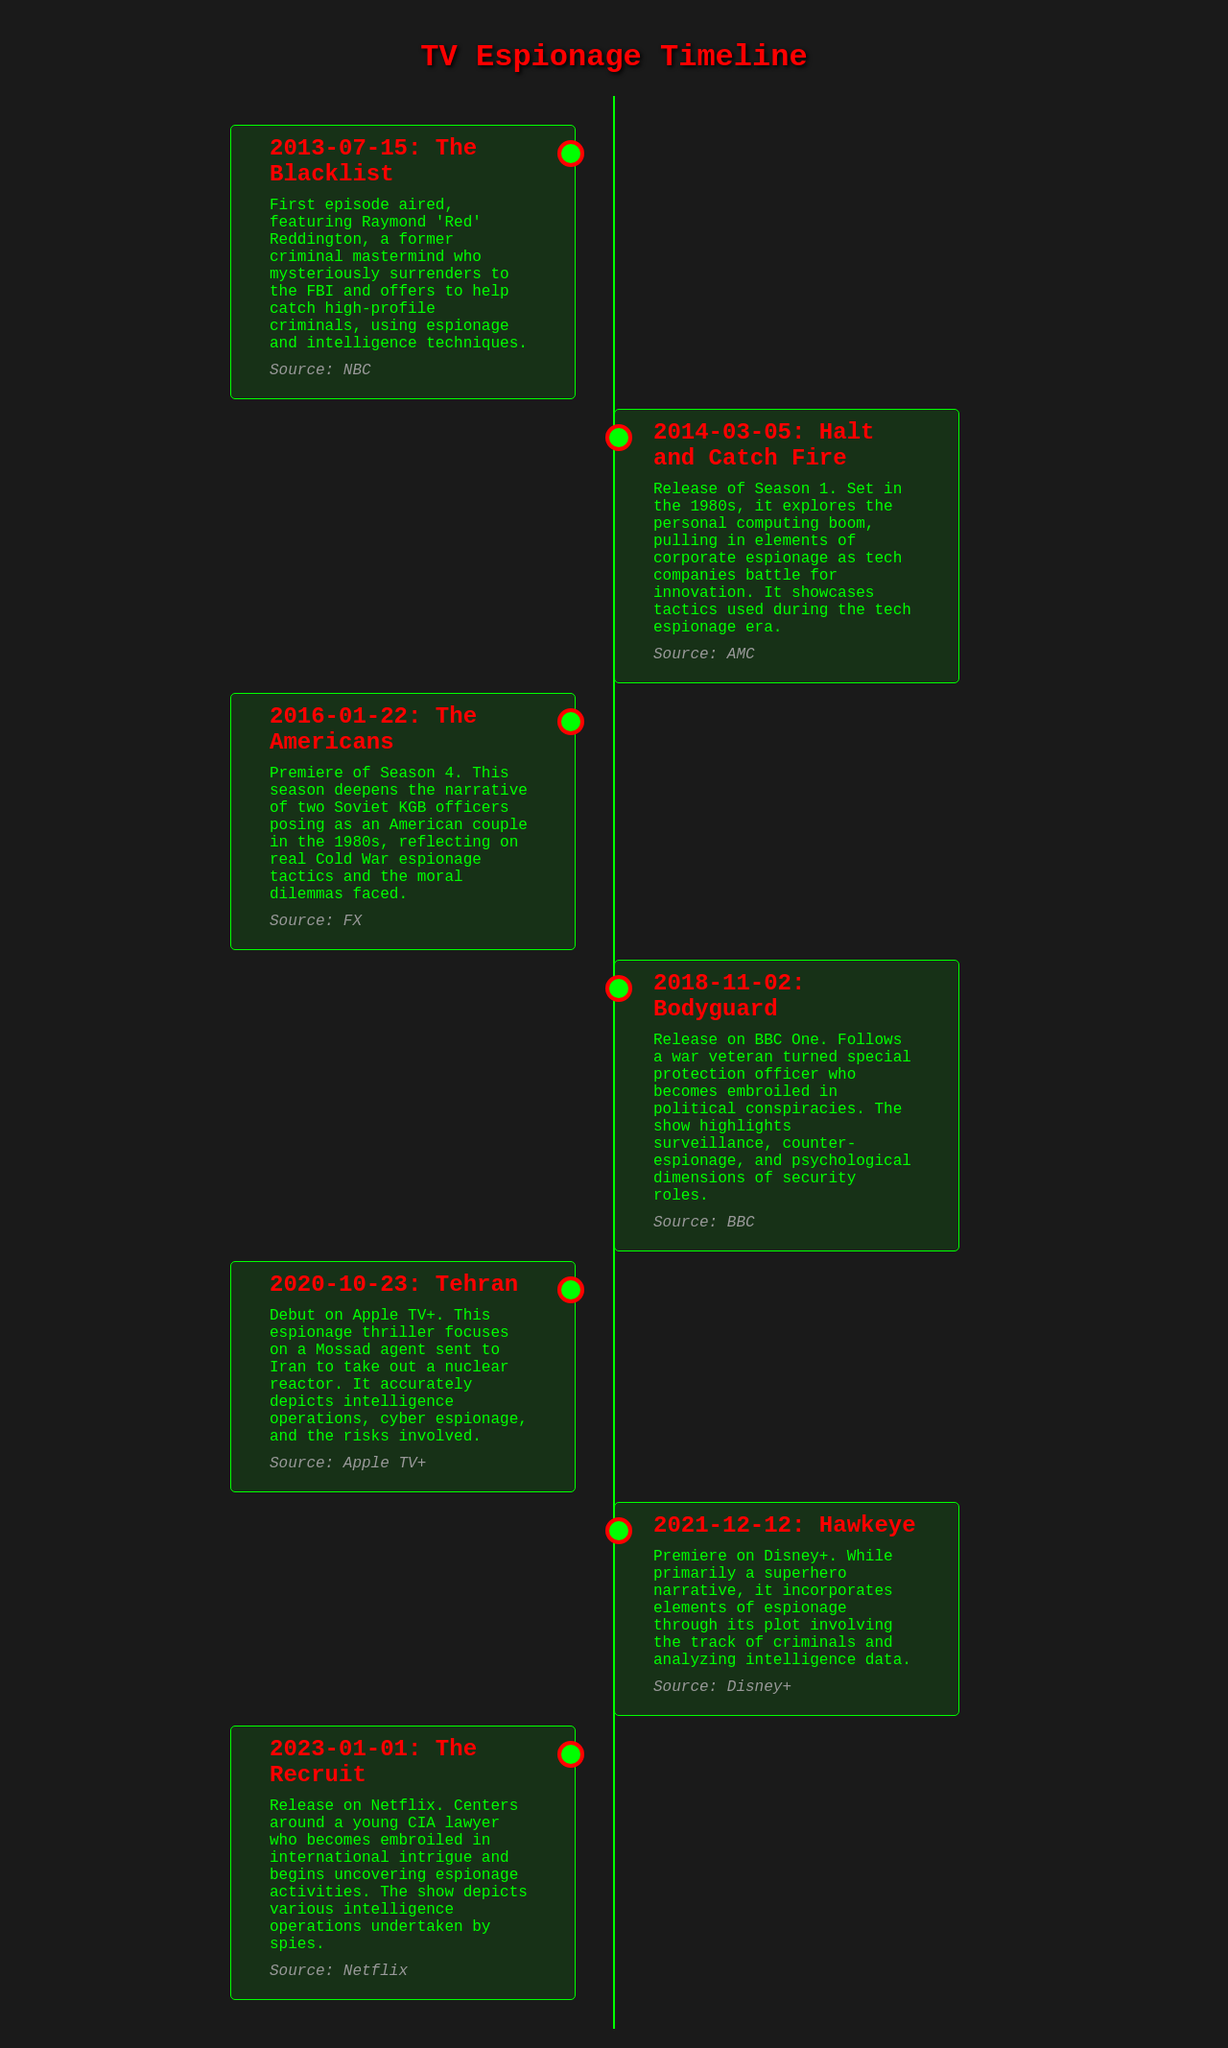What is the first TV show mentioned in the timeline? The first entry in the timeline is "The Blacklist," which aired first on July 15, 2013.
Answer: The Blacklist What date did "Tehran" premiere? The timeline entry for "Tehran" indicates it premiered on October 23, 2020.
Answer: October 23, 2020 Which show features KGB officers posing as an American couple? The show "The Americans" is noted for this narrative in its Season 4.
Answer: The Americans How many events listed occurred in 2018? There is one event listed for 2018, which is "Bodyguard."
Answer: 1 What network aired "Halt and Catch Fire"? The timeline specifies that "Halt and Catch Fire" was released on AMC.
Answer: AMC Which show portrays a young CIA lawyer? The entry for "The Recruit" focuses on a young CIA lawyer navigating espionage.
Answer: The Recruit In which year did "Hawkeye" premiere? The timeline notes that "Hawkeye" premiered on December 12, 2021.
Answer: 2021 What major theme does "Bodyguard" incorporate? The document describes "Bodyguard" as highlighting surveillance and counter-espionage themes.
Answer: Surveillance Which show is described as a Mossad agent's mission? "Tehran" is focused on a Mossad agent's operations in Iran.
Answer: Tehran 